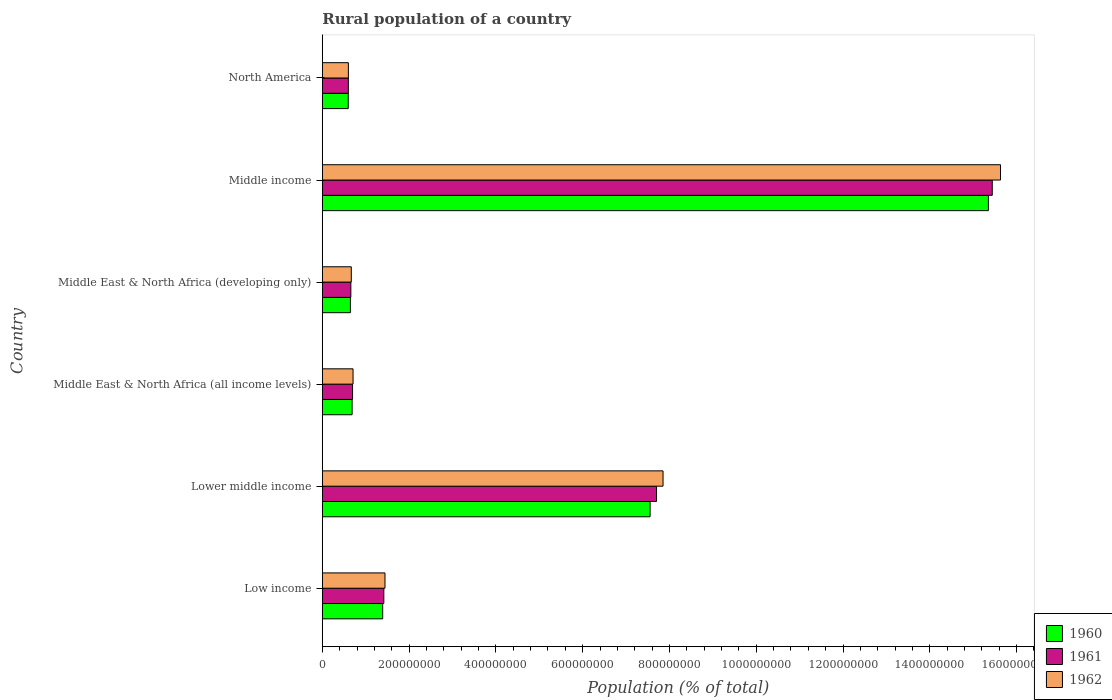Are the number of bars per tick equal to the number of legend labels?
Offer a very short reply. Yes. How many bars are there on the 2nd tick from the top?
Provide a succinct answer. 3. How many bars are there on the 6th tick from the bottom?
Your answer should be compact. 3. What is the label of the 5th group of bars from the top?
Make the answer very short. Lower middle income. In how many cases, is the number of bars for a given country not equal to the number of legend labels?
Provide a succinct answer. 0. What is the rural population in 1962 in Low income?
Ensure brevity in your answer.  1.44e+08. Across all countries, what is the maximum rural population in 1960?
Keep it short and to the point. 1.53e+09. Across all countries, what is the minimum rural population in 1960?
Provide a succinct answer. 5.97e+07. In which country was the rural population in 1960 maximum?
Offer a very short reply. Middle income. What is the total rural population in 1962 in the graph?
Make the answer very short. 2.69e+09. What is the difference between the rural population in 1962 in Lower middle income and that in Middle East & North Africa (all income levels)?
Keep it short and to the point. 7.14e+08. What is the difference between the rural population in 1960 in Lower middle income and the rural population in 1962 in Middle East & North Africa (all income levels)?
Your answer should be compact. 6.85e+08. What is the average rural population in 1960 per country?
Your answer should be very brief. 4.37e+08. What is the difference between the rural population in 1961 and rural population in 1962 in Middle East & North Africa (all income levels)?
Provide a short and direct response. -1.09e+06. In how many countries, is the rural population in 1960 greater than 1000000000 %?
Ensure brevity in your answer.  1. What is the ratio of the rural population in 1962 in Low income to that in Lower middle income?
Give a very brief answer. 0.18. Is the rural population in 1960 in Low income less than that in Middle East & North Africa (all income levels)?
Your response must be concise. No. Is the difference between the rural population in 1961 in Low income and Middle income greater than the difference between the rural population in 1962 in Low income and Middle income?
Your answer should be compact. Yes. What is the difference between the highest and the second highest rural population in 1961?
Provide a succinct answer. 7.74e+08. What is the difference between the highest and the lowest rural population in 1961?
Your answer should be compact. 1.48e+09. Is the sum of the rural population in 1962 in Lower middle income and Middle income greater than the maximum rural population in 1960 across all countries?
Your response must be concise. Yes. What does the 1st bar from the top in Lower middle income represents?
Give a very brief answer. 1962. What does the 1st bar from the bottom in Lower middle income represents?
Give a very brief answer. 1960. Is it the case that in every country, the sum of the rural population in 1962 and rural population in 1961 is greater than the rural population in 1960?
Make the answer very short. Yes. Are the values on the major ticks of X-axis written in scientific E-notation?
Keep it short and to the point. No. Does the graph contain any zero values?
Offer a terse response. No. Does the graph contain grids?
Your answer should be very brief. No. What is the title of the graph?
Offer a terse response. Rural population of a country. What is the label or title of the X-axis?
Provide a succinct answer. Population (% of total). What is the label or title of the Y-axis?
Ensure brevity in your answer.  Country. What is the Population (% of total) in 1960 in Low income?
Offer a very short reply. 1.39e+08. What is the Population (% of total) of 1961 in Low income?
Provide a succinct answer. 1.42e+08. What is the Population (% of total) of 1962 in Low income?
Your answer should be very brief. 1.44e+08. What is the Population (% of total) of 1960 in Lower middle income?
Keep it short and to the point. 7.55e+08. What is the Population (% of total) in 1961 in Lower middle income?
Your response must be concise. 7.70e+08. What is the Population (% of total) in 1962 in Lower middle income?
Your response must be concise. 7.85e+08. What is the Population (% of total) in 1960 in Middle East & North Africa (all income levels)?
Your answer should be compact. 6.86e+07. What is the Population (% of total) of 1961 in Middle East & North Africa (all income levels)?
Provide a short and direct response. 6.97e+07. What is the Population (% of total) in 1962 in Middle East & North Africa (all income levels)?
Make the answer very short. 7.08e+07. What is the Population (% of total) in 1960 in Middle East & North Africa (developing only)?
Give a very brief answer. 6.47e+07. What is the Population (% of total) of 1961 in Middle East & North Africa (developing only)?
Make the answer very short. 6.57e+07. What is the Population (% of total) in 1962 in Middle East & North Africa (developing only)?
Provide a succinct answer. 6.67e+07. What is the Population (% of total) of 1960 in Middle income?
Offer a terse response. 1.53e+09. What is the Population (% of total) of 1961 in Middle income?
Your answer should be very brief. 1.54e+09. What is the Population (% of total) of 1962 in Middle income?
Provide a short and direct response. 1.56e+09. What is the Population (% of total) of 1960 in North America?
Make the answer very short. 5.97e+07. What is the Population (% of total) in 1961 in North America?
Your response must be concise. 6.00e+07. What is the Population (% of total) in 1962 in North America?
Your answer should be compact. 6.00e+07. Across all countries, what is the maximum Population (% of total) of 1960?
Your response must be concise. 1.53e+09. Across all countries, what is the maximum Population (% of total) of 1961?
Your response must be concise. 1.54e+09. Across all countries, what is the maximum Population (% of total) in 1962?
Ensure brevity in your answer.  1.56e+09. Across all countries, what is the minimum Population (% of total) of 1960?
Your answer should be compact. 5.97e+07. Across all countries, what is the minimum Population (% of total) in 1961?
Your answer should be very brief. 6.00e+07. Across all countries, what is the minimum Population (% of total) of 1962?
Provide a succinct answer. 6.00e+07. What is the total Population (% of total) of 1960 in the graph?
Offer a very short reply. 2.62e+09. What is the total Population (% of total) in 1961 in the graph?
Make the answer very short. 2.65e+09. What is the total Population (% of total) in 1962 in the graph?
Provide a succinct answer. 2.69e+09. What is the difference between the Population (% of total) of 1960 in Low income and that in Lower middle income?
Give a very brief answer. -6.16e+08. What is the difference between the Population (% of total) of 1961 in Low income and that in Lower middle income?
Your answer should be compact. -6.28e+08. What is the difference between the Population (% of total) of 1962 in Low income and that in Lower middle income?
Keep it short and to the point. -6.41e+08. What is the difference between the Population (% of total) in 1960 in Low income and that in Middle East & North Africa (all income levels)?
Your response must be concise. 7.05e+07. What is the difference between the Population (% of total) in 1961 in Low income and that in Middle East & North Africa (all income levels)?
Provide a short and direct response. 7.20e+07. What is the difference between the Population (% of total) in 1962 in Low income and that in Middle East & North Africa (all income levels)?
Provide a succinct answer. 7.36e+07. What is the difference between the Population (% of total) of 1960 in Low income and that in Middle East & North Africa (developing only)?
Your answer should be compact. 7.44e+07. What is the difference between the Population (% of total) in 1961 in Low income and that in Middle East & North Africa (developing only)?
Ensure brevity in your answer.  7.60e+07. What is the difference between the Population (% of total) in 1962 in Low income and that in Middle East & North Africa (developing only)?
Give a very brief answer. 7.76e+07. What is the difference between the Population (% of total) of 1960 in Low income and that in Middle income?
Provide a succinct answer. -1.40e+09. What is the difference between the Population (% of total) of 1961 in Low income and that in Middle income?
Your response must be concise. -1.40e+09. What is the difference between the Population (% of total) of 1962 in Low income and that in Middle income?
Make the answer very short. -1.42e+09. What is the difference between the Population (% of total) of 1960 in Low income and that in North America?
Offer a terse response. 7.94e+07. What is the difference between the Population (% of total) in 1961 in Low income and that in North America?
Your answer should be compact. 8.18e+07. What is the difference between the Population (% of total) in 1962 in Low income and that in North America?
Ensure brevity in your answer.  8.43e+07. What is the difference between the Population (% of total) in 1960 in Lower middle income and that in Middle East & North Africa (all income levels)?
Your answer should be very brief. 6.87e+08. What is the difference between the Population (% of total) of 1961 in Lower middle income and that in Middle East & North Africa (all income levels)?
Make the answer very short. 7.01e+08. What is the difference between the Population (% of total) of 1962 in Lower middle income and that in Middle East & North Africa (all income levels)?
Your response must be concise. 7.14e+08. What is the difference between the Population (% of total) of 1960 in Lower middle income and that in Middle East & North Africa (developing only)?
Give a very brief answer. 6.91e+08. What is the difference between the Population (% of total) of 1961 in Lower middle income and that in Middle East & North Africa (developing only)?
Give a very brief answer. 7.04e+08. What is the difference between the Population (% of total) of 1962 in Lower middle income and that in Middle East & North Africa (developing only)?
Ensure brevity in your answer.  7.18e+08. What is the difference between the Population (% of total) of 1960 in Lower middle income and that in Middle income?
Make the answer very short. -7.80e+08. What is the difference between the Population (% of total) in 1961 in Lower middle income and that in Middle income?
Keep it short and to the point. -7.74e+08. What is the difference between the Population (% of total) in 1962 in Lower middle income and that in Middle income?
Offer a very short reply. -7.78e+08. What is the difference between the Population (% of total) in 1960 in Lower middle income and that in North America?
Provide a short and direct response. 6.96e+08. What is the difference between the Population (% of total) of 1961 in Lower middle income and that in North America?
Keep it short and to the point. 7.10e+08. What is the difference between the Population (% of total) of 1962 in Lower middle income and that in North America?
Keep it short and to the point. 7.25e+08. What is the difference between the Population (% of total) in 1960 in Middle East & North Africa (all income levels) and that in Middle East & North Africa (developing only)?
Your response must be concise. 3.92e+06. What is the difference between the Population (% of total) of 1961 in Middle East & North Africa (all income levels) and that in Middle East & North Africa (developing only)?
Your answer should be compact. 3.97e+06. What is the difference between the Population (% of total) in 1962 in Middle East & North Africa (all income levels) and that in Middle East & North Africa (developing only)?
Your answer should be very brief. 4.04e+06. What is the difference between the Population (% of total) of 1960 in Middle East & North Africa (all income levels) and that in Middle income?
Your response must be concise. -1.47e+09. What is the difference between the Population (% of total) in 1961 in Middle East & North Africa (all income levels) and that in Middle income?
Give a very brief answer. -1.47e+09. What is the difference between the Population (% of total) of 1962 in Middle East & North Africa (all income levels) and that in Middle income?
Offer a terse response. -1.49e+09. What is the difference between the Population (% of total) in 1960 in Middle East & North Africa (all income levels) and that in North America?
Your answer should be compact. 8.89e+06. What is the difference between the Population (% of total) of 1961 in Middle East & North Africa (all income levels) and that in North America?
Give a very brief answer. 9.73e+06. What is the difference between the Population (% of total) of 1962 in Middle East & North Africa (all income levels) and that in North America?
Provide a short and direct response. 1.07e+07. What is the difference between the Population (% of total) of 1960 in Middle East & North Africa (developing only) and that in Middle income?
Ensure brevity in your answer.  -1.47e+09. What is the difference between the Population (% of total) in 1961 in Middle East & North Africa (developing only) and that in Middle income?
Your answer should be very brief. -1.48e+09. What is the difference between the Population (% of total) of 1962 in Middle East & North Africa (developing only) and that in Middle income?
Your response must be concise. -1.50e+09. What is the difference between the Population (% of total) of 1960 in Middle East & North Africa (developing only) and that in North America?
Provide a short and direct response. 4.97e+06. What is the difference between the Population (% of total) of 1961 in Middle East & North Africa (developing only) and that in North America?
Your answer should be very brief. 5.76e+06. What is the difference between the Population (% of total) of 1962 in Middle East & North Africa (developing only) and that in North America?
Your answer should be compact. 6.70e+06. What is the difference between the Population (% of total) of 1960 in Middle income and that in North America?
Offer a terse response. 1.48e+09. What is the difference between the Population (% of total) in 1961 in Middle income and that in North America?
Make the answer very short. 1.48e+09. What is the difference between the Population (% of total) in 1962 in Middle income and that in North America?
Offer a terse response. 1.50e+09. What is the difference between the Population (% of total) in 1960 in Low income and the Population (% of total) in 1961 in Lower middle income?
Provide a short and direct response. -6.31e+08. What is the difference between the Population (% of total) of 1960 in Low income and the Population (% of total) of 1962 in Lower middle income?
Make the answer very short. -6.46e+08. What is the difference between the Population (% of total) in 1961 in Low income and the Population (% of total) in 1962 in Lower middle income?
Offer a terse response. -6.43e+08. What is the difference between the Population (% of total) in 1960 in Low income and the Population (% of total) in 1961 in Middle East & North Africa (all income levels)?
Your answer should be very brief. 6.94e+07. What is the difference between the Population (% of total) of 1960 in Low income and the Population (% of total) of 1962 in Middle East & North Africa (all income levels)?
Give a very brief answer. 6.83e+07. What is the difference between the Population (% of total) in 1961 in Low income and the Population (% of total) in 1962 in Middle East & North Africa (all income levels)?
Your answer should be very brief. 7.09e+07. What is the difference between the Population (% of total) in 1960 in Low income and the Population (% of total) in 1961 in Middle East & North Africa (developing only)?
Provide a short and direct response. 7.34e+07. What is the difference between the Population (% of total) in 1960 in Low income and the Population (% of total) in 1962 in Middle East & North Africa (developing only)?
Your answer should be very brief. 7.24e+07. What is the difference between the Population (% of total) in 1961 in Low income and the Population (% of total) in 1962 in Middle East & North Africa (developing only)?
Give a very brief answer. 7.50e+07. What is the difference between the Population (% of total) of 1960 in Low income and the Population (% of total) of 1961 in Middle income?
Provide a succinct answer. -1.40e+09. What is the difference between the Population (% of total) of 1960 in Low income and the Population (% of total) of 1962 in Middle income?
Keep it short and to the point. -1.42e+09. What is the difference between the Population (% of total) in 1961 in Low income and the Population (% of total) in 1962 in Middle income?
Ensure brevity in your answer.  -1.42e+09. What is the difference between the Population (% of total) of 1960 in Low income and the Population (% of total) of 1961 in North America?
Your response must be concise. 7.92e+07. What is the difference between the Population (% of total) in 1960 in Low income and the Population (% of total) in 1962 in North America?
Your answer should be very brief. 7.91e+07. What is the difference between the Population (% of total) of 1961 in Low income and the Population (% of total) of 1962 in North America?
Offer a very short reply. 8.17e+07. What is the difference between the Population (% of total) in 1960 in Lower middle income and the Population (% of total) in 1961 in Middle East & North Africa (all income levels)?
Ensure brevity in your answer.  6.86e+08. What is the difference between the Population (% of total) in 1960 in Lower middle income and the Population (% of total) in 1962 in Middle East & North Africa (all income levels)?
Ensure brevity in your answer.  6.85e+08. What is the difference between the Population (% of total) in 1961 in Lower middle income and the Population (% of total) in 1962 in Middle East & North Africa (all income levels)?
Give a very brief answer. 6.99e+08. What is the difference between the Population (% of total) in 1960 in Lower middle income and the Population (% of total) in 1961 in Middle East & North Africa (developing only)?
Provide a short and direct response. 6.90e+08. What is the difference between the Population (% of total) in 1960 in Lower middle income and the Population (% of total) in 1962 in Middle East & North Africa (developing only)?
Your answer should be very brief. 6.89e+08. What is the difference between the Population (% of total) of 1961 in Lower middle income and the Population (% of total) of 1962 in Middle East & North Africa (developing only)?
Offer a terse response. 7.03e+08. What is the difference between the Population (% of total) of 1960 in Lower middle income and the Population (% of total) of 1961 in Middle income?
Offer a very short reply. -7.89e+08. What is the difference between the Population (% of total) of 1960 in Lower middle income and the Population (% of total) of 1962 in Middle income?
Make the answer very short. -8.08e+08. What is the difference between the Population (% of total) of 1961 in Lower middle income and the Population (% of total) of 1962 in Middle income?
Your response must be concise. -7.93e+08. What is the difference between the Population (% of total) of 1960 in Lower middle income and the Population (% of total) of 1961 in North America?
Offer a terse response. 6.95e+08. What is the difference between the Population (% of total) in 1960 in Lower middle income and the Population (% of total) in 1962 in North America?
Keep it short and to the point. 6.95e+08. What is the difference between the Population (% of total) of 1961 in Lower middle income and the Population (% of total) of 1962 in North America?
Provide a short and direct response. 7.10e+08. What is the difference between the Population (% of total) in 1960 in Middle East & North Africa (all income levels) and the Population (% of total) in 1961 in Middle East & North Africa (developing only)?
Your answer should be compact. 2.91e+06. What is the difference between the Population (% of total) in 1960 in Middle East & North Africa (all income levels) and the Population (% of total) in 1962 in Middle East & North Africa (developing only)?
Offer a very short reply. 1.89e+06. What is the difference between the Population (% of total) in 1961 in Middle East & North Africa (all income levels) and the Population (% of total) in 1962 in Middle East & North Africa (developing only)?
Make the answer very short. 2.95e+06. What is the difference between the Population (% of total) of 1960 in Middle East & North Africa (all income levels) and the Population (% of total) of 1961 in Middle income?
Offer a very short reply. -1.48e+09. What is the difference between the Population (% of total) of 1960 in Middle East & North Africa (all income levels) and the Population (% of total) of 1962 in Middle income?
Keep it short and to the point. -1.49e+09. What is the difference between the Population (% of total) of 1961 in Middle East & North Africa (all income levels) and the Population (% of total) of 1962 in Middle income?
Your response must be concise. -1.49e+09. What is the difference between the Population (% of total) in 1960 in Middle East & North Africa (all income levels) and the Population (% of total) in 1961 in North America?
Ensure brevity in your answer.  8.68e+06. What is the difference between the Population (% of total) in 1960 in Middle East & North Africa (all income levels) and the Population (% of total) in 1962 in North America?
Ensure brevity in your answer.  8.59e+06. What is the difference between the Population (% of total) of 1961 in Middle East & North Africa (all income levels) and the Population (% of total) of 1962 in North America?
Your answer should be compact. 9.65e+06. What is the difference between the Population (% of total) of 1960 in Middle East & North Africa (developing only) and the Population (% of total) of 1961 in Middle income?
Keep it short and to the point. -1.48e+09. What is the difference between the Population (% of total) of 1960 in Middle East & North Africa (developing only) and the Population (% of total) of 1962 in Middle income?
Provide a short and direct response. -1.50e+09. What is the difference between the Population (% of total) of 1961 in Middle East & North Africa (developing only) and the Population (% of total) of 1962 in Middle income?
Your answer should be compact. -1.50e+09. What is the difference between the Population (% of total) of 1960 in Middle East & North Africa (developing only) and the Population (% of total) of 1961 in North America?
Offer a very short reply. 4.76e+06. What is the difference between the Population (% of total) of 1960 in Middle East & North Africa (developing only) and the Population (% of total) of 1962 in North America?
Give a very brief answer. 4.67e+06. What is the difference between the Population (% of total) of 1961 in Middle East & North Africa (developing only) and the Population (% of total) of 1962 in North America?
Your answer should be very brief. 5.68e+06. What is the difference between the Population (% of total) in 1960 in Middle income and the Population (% of total) in 1961 in North America?
Provide a succinct answer. 1.48e+09. What is the difference between the Population (% of total) in 1960 in Middle income and the Population (% of total) in 1962 in North America?
Make the answer very short. 1.47e+09. What is the difference between the Population (% of total) in 1961 in Middle income and the Population (% of total) in 1962 in North America?
Offer a terse response. 1.48e+09. What is the average Population (% of total) of 1960 per country?
Provide a short and direct response. 4.37e+08. What is the average Population (% of total) of 1961 per country?
Your answer should be very brief. 4.42e+08. What is the average Population (% of total) in 1962 per country?
Give a very brief answer. 4.48e+08. What is the difference between the Population (% of total) of 1960 and Population (% of total) of 1961 in Low income?
Give a very brief answer. -2.61e+06. What is the difference between the Population (% of total) of 1960 and Population (% of total) of 1962 in Low income?
Provide a short and direct response. -5.27e+06. What is the difference between the Population (% of total) in 1961 and Population (% of total) in 1962 in Low income?
Give a very brief answer. -2.66e+06. What is the difference between the Population (% of total) in 1960 and Population (% of total) in 1961 in Lower middle income?
Provide a succinct answer. -1.49e+07. What is the difference between the Population (% of total) of 1960 and Population (% of total) of 1962 in Lower middle income?
Give a very brief answer. -2.98e+07. What is the difference between the Population (% of total) in 1961 and Population (% of total) in 1962 in Lower middle income?
Your response must be concise. -1.50e+07. What is the difference between the Population (% of total) of 1960 and Population (% of total) of 1961 in Middle East & North Africa (all income levels)?
Your answer should be compact. -1.05e+06. What is the difference between the Population (% of total) in 1960 and Population (% of total) in 1962 in Middle East & North Africa (all income levels)?
Your answer should be very brief. -2.14e+06. What is the difference between the Population (% of total) in 1961 and Population (% of total) in 1962 in Middle East & North Africa (all income levels)?
Provide a succinct answer. -1.09e+06. What is the difference between the Population (% of total) of 1960 and Population (% of total) of 1961 in Middle East & North Africa (developing only)?
Your response must be concise. -1.00e+06. What is the difference between the Population (% of total) of 1960 and Population (% of total) of 1962 in Middle East & North Africa (developing only)?
Provide a short and direct response. -2.03e+06. What is the difference between the Population (% of total) of 1961 and Population (% of total) of 1962 in Middle East & North Africa (developing only)?
Give a very brief answer. -1.02e+06. What is the difference between the Population (% of total) of 1960 and Population (% of total) of 1961 in Middle income?
Provide a succinct answer. -8.92e+06. What is the difference between the Population (% of total) of 1960 and Population (% of total) of 1962 in Middle income?
Give a very brief answer. -2.80e+07. What is the difference between the Population (% of total) of 1961 and Population (% of total) of 1962 in Middle income?
Provide a short and direct response. -1.90e+07. What is the difference between the Population (% of total) in 1960 and Population (% of total) in 1961 in North America?
Your answer should be very brief. -2.07e+05. What is the difference between the Population (% of total) of 1960 and Population (% of total) of 1962 in North America?
Make the answer very short. -2.92e+05. What is the difference between the Population (% of total) of 1961 and Population (% of total) of 1962 in North America?
Provide a short and direct response. -8.48e+04. What is the ratio of the Population (% of total) of 1960 in Low income to that in Lower middle income?
Your answer should be very brief. 0.18. What is the ratio of the Population (% of total) in 1961 in Low income to that in Lower middle income?
Your answer should be very brief. 0.18. What is the ratio of the Population (% of total) in 1962 in Low income to that in Lower middle income?
Make the answer very short. 0.18. What is the ratio of the Population (% of total) in 1960 in Low income to that in Middle East & North Africa (all income levels)?
Your answer should be compact. 2.03. What is the ratio of the Population (% of total) in 1961 in Low income to that in Middle East & North Africa (all income levels)?
Your answer should be compact. 2.03. What is the ratio of the Population (% of total) in 1962 in Low income to that in Middle East & North Africa (all income levels)?
Your answer should be compact. 2.04. What is the ratio of the Population (% of total) of 1960 in Low income to that in Middle East & North Africa (developing only)?
Provide a short and direct response. 2.15. What is the ratio of the Population (% of total) in 1961 in Low income to that in Middle East & North Africa (developing only)?
Your response must be concise. 2.16. What is the ratio of the Population (% of total) in 1962 in Low income to that in Middle East & North Africa (developing only)?
Offer a very short reply. 2.16. What is the ratio of the Population (% of total) in 1960 in Low income to that in Middle income?
Offer a terse response. 0.09. What is the ratio of the Population (% of total) in 1961 in Low income to that in Middle income?
Give a very brief answer. 0.09. What is the ratio of the Population (% of total) in 1962 in Low income to that in Middle income?
Make the answer very short. 0.09. What is the ratio of the Population (% of total) of 1960 in Low income to that in North America?
Provide a succinct answer. 2.33. What is the ratio of the Population (% of total) in 1961 in Low income to that in North America?
Your response must be concise. 2.36. What is the ratio of the Population (% of total) of 1962 in Low income to that in North America?
Your answer should be very brief. 2.4. What is the ratio of the Population (% of total) of 1960 in Lower middle income to that in Middle East & North Africa (all income levels)?
Ensure brevity in your answer.  11.01. What is the ratio of the Population (% of total) in 1961 in Lower middle income to that in Middle East & North Africa (all income levels)?
Provide a short and direct response. 11.05. What is the ratio of the Population (% of total) in 1962 in Lower middle income to that in Middle East & North Africa (all income levels)?
Offer a very short reply. 11.09. What is the ratio of the Population (% of total) in 1960 in Lower middle income to that in Middle East & North Africa (developing only)?
Provide a succinct answer. 11.67. What is the ratio of the Population (% of total) in 1961 in Lower middle income to that in Middle East & North Africa (developing only)?
Your answer should be very brief. 11.72. What is the ratio of the Population (% of total) in 1962 in Lower middle income to that in Middle East & North Africa (developing only)?
Keep it short and to the point. 11.76. What is the ratio of the Population (% of total) of 1960 in Lower middle income to that in Middle income?
Give a very brief answer. 0.49. What is the ratio of the Population (% of total) of 1961 in Lower middle income to that in Middle income?
Provide a succinct answer. 0.5. What is the ratio of the Population (% of total) of 1962 in Lower middle income to that in Middle income?
Keep it short and to the point. 0.5. What is the ratio of the Population (% of total) in 1960 in Lower middle income to that in North America?
Your answer should be compact. 12.64. What is the ratio of the Population (% of total) in 1961 in Lower middle income to that in North America?
Make the answer very short. 12.85. What is the ratio of the Population (% of total) of 1962 in Lower middle income to that in North America?
Your answer should be compact. 13.08. What is the ratio of the Population (% of total) of 1960 in Middle East & North Africa (all income levels) to that in Middle East & North Africa (developing only)?
Your answer should be very brief. 1.06. What is the ratio of the Population (% of total) of 1961 in Middle East & North Africa (all income levels) to that in Middle East & North Africa (developing only)?
Make the answer very short. 1.06. What is the ratio of the Population (% of total) of 1962 in Middle East & North Africa (all income levels) to that in Middle East & North Africa (developing only)?
Provide a short and direct response. 1.06. What is the ratio of the Population (% of total) in 1960 in Middle East & North Africa (all income levels) to that in Middle income?
Your response must be concise. 0.04. What is the ratio of the Population (% of total) of 1961 in Middle East & North Africa (all income levels) to that in Middle income?
Keep it short and to the point. 0.05. What is the ratio of the Population (% of total) in 1962 in Middle East & North Africa (all income levels) to that in Middle income?
Give a very brief answer. 0.05. What is the ratio of the Population (% of total) in 1960 in Middle East & North Africa (all income levels) to that in North America?
Offer a very short reply. 1.15. What is the ratio of the Population (% of total) in 1961 in Middle East & North Africa (all income levels) to that in North America?
Offer a very short reply. 1.16. What is the ratio of the Population (% of total) in 1962 in Middle East & North Africa (all income levels) to that in North America?
Make the answer very short. 1.18. What is the ratio of the Population (% of total) of 1960 in Middle East & North Africa (developing only) to that in Middle income?
Your response must be concise. 0.04. What is the ratio of the Population (% of total) of 1961 in Middle East & North Africa (developing only) to that in Middle income?
Offer a terse response. 0.04. What is the ratio of the Population (% of total) of 1962 in Middle East & North Africa (developing only) to that in Middle income?
Ensure brevity in your answer.  0.04. What is the ratio of the Population (% of total) of 1960 in Middle East & North Africa (developing only) to that in North America?
Provide a succinct answer. 1.08. What is the ratio of the Population (% of total) of 1961 in Middle East & North Africa (developing only) to that in North America?
Ensure brevity in your answer.  1.1. What is the ratio of the Population (% of total) in 1962 in Middle East & North Africa (developing only) to that in North America?
Your response must be concise. 1.11. What is the ratio of the Population (% of total) in 1960 in Middle income to that in North America?
Give a very brief answer. 25.69. What is the ratio of the Population (% of total) in 1961 in Middle income to that in North America?
Make the answer very short. 25.75. What is the ratio of the Population (% of total) in 1962 in Middle income to that in North America?
Your answer should be compact. 26.03. What is the difference between the highest and the second highest Population (% of total) of 1960?
Make the answer very short. 7.80e+08. What is the difference between the highest and the second highest Population (% of total) in 1961?
Your answer should be very brief. 7.74e+08. What is the difference between the highest and the second highest Population (% of total) of 1962?
Keep it short and to the point. 7.78e+08. What is the difference between the highest and the lowest Population (% of total) in 1960?
Provide a succinct answer. 1.48e+09. What is the difference between the highest and the lowest Population (% of total) in 1961?
Your response must be concise. 1.48e+09. What is the difference between the highest and the lowest Population (% of total) of 1962?
Make the answer very short. 1.50e+09. 